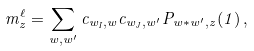Convert formula to latex. <formula><loc_0><loc_0><loc_500><loc_500>m ^ { \ell } _ { z } = \sum _ { w , w ^ { \prime } } c _ { w _ { I } , w } c _ { w _ { J } , w ^ { \prime } } P _ { w \ast w ^ { \prime } , z } ( 1 ) \, ,</formula> 